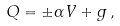<formula> <loc_0><loc_0><loc_500><loc_500>Q = \pm \alpha V + g \, ,</formula> 